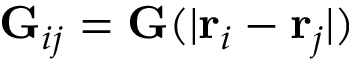Convert formula to latex. <formula><loc_0><loc_0><loc_500><loc_500>G _ { i j } = G ( | { r } _ { i } - { r } _ { j } | )</formula> 